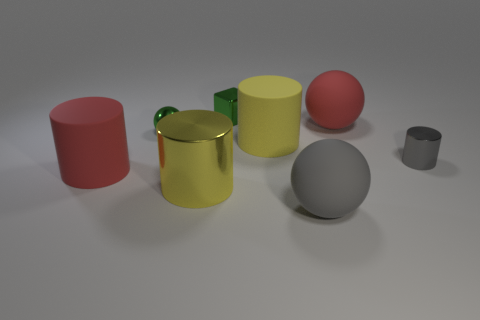Are there any other shiny objects of the same shape as the big gray object?
Give a very brief answer. Yes. Is the number of shiny objects that are left of the gray ball greater than the number of tiny metal cubes?
Make the answer very short. Yes. How many metallic things are gray objects or red balls?
Provide a succinct answer. 1. What size is the object that is both to the left of the tiny shiny cube and behind the small gray metal thing?
Make the answer very short. Small. Are there any green shiny cubes that are to the left of the yellow matte thing to the left of the tiny gray thing?
Keep it short and to the point. Yes. How many large yellow things are on the right side of the gray metal thing?
Your answer should be compact. 0. The other large thing that is the same shape as the big gray object is what color?
Provide a short and direct response. Red. Is the material of the red object in front of the tiny metal cylinder the same as the sphere that is in front of the red cylinder?
Make the answer very short. Yes. There is a large metal cylinder; is it the same color as the large matte sphere that is behind the gray ball?
Give a very brief answer. No. What shape is the small shiny object that is to the left of the gray rubber thing and in front of the tiny metallic block?
Offer a terse response. Sphere. 